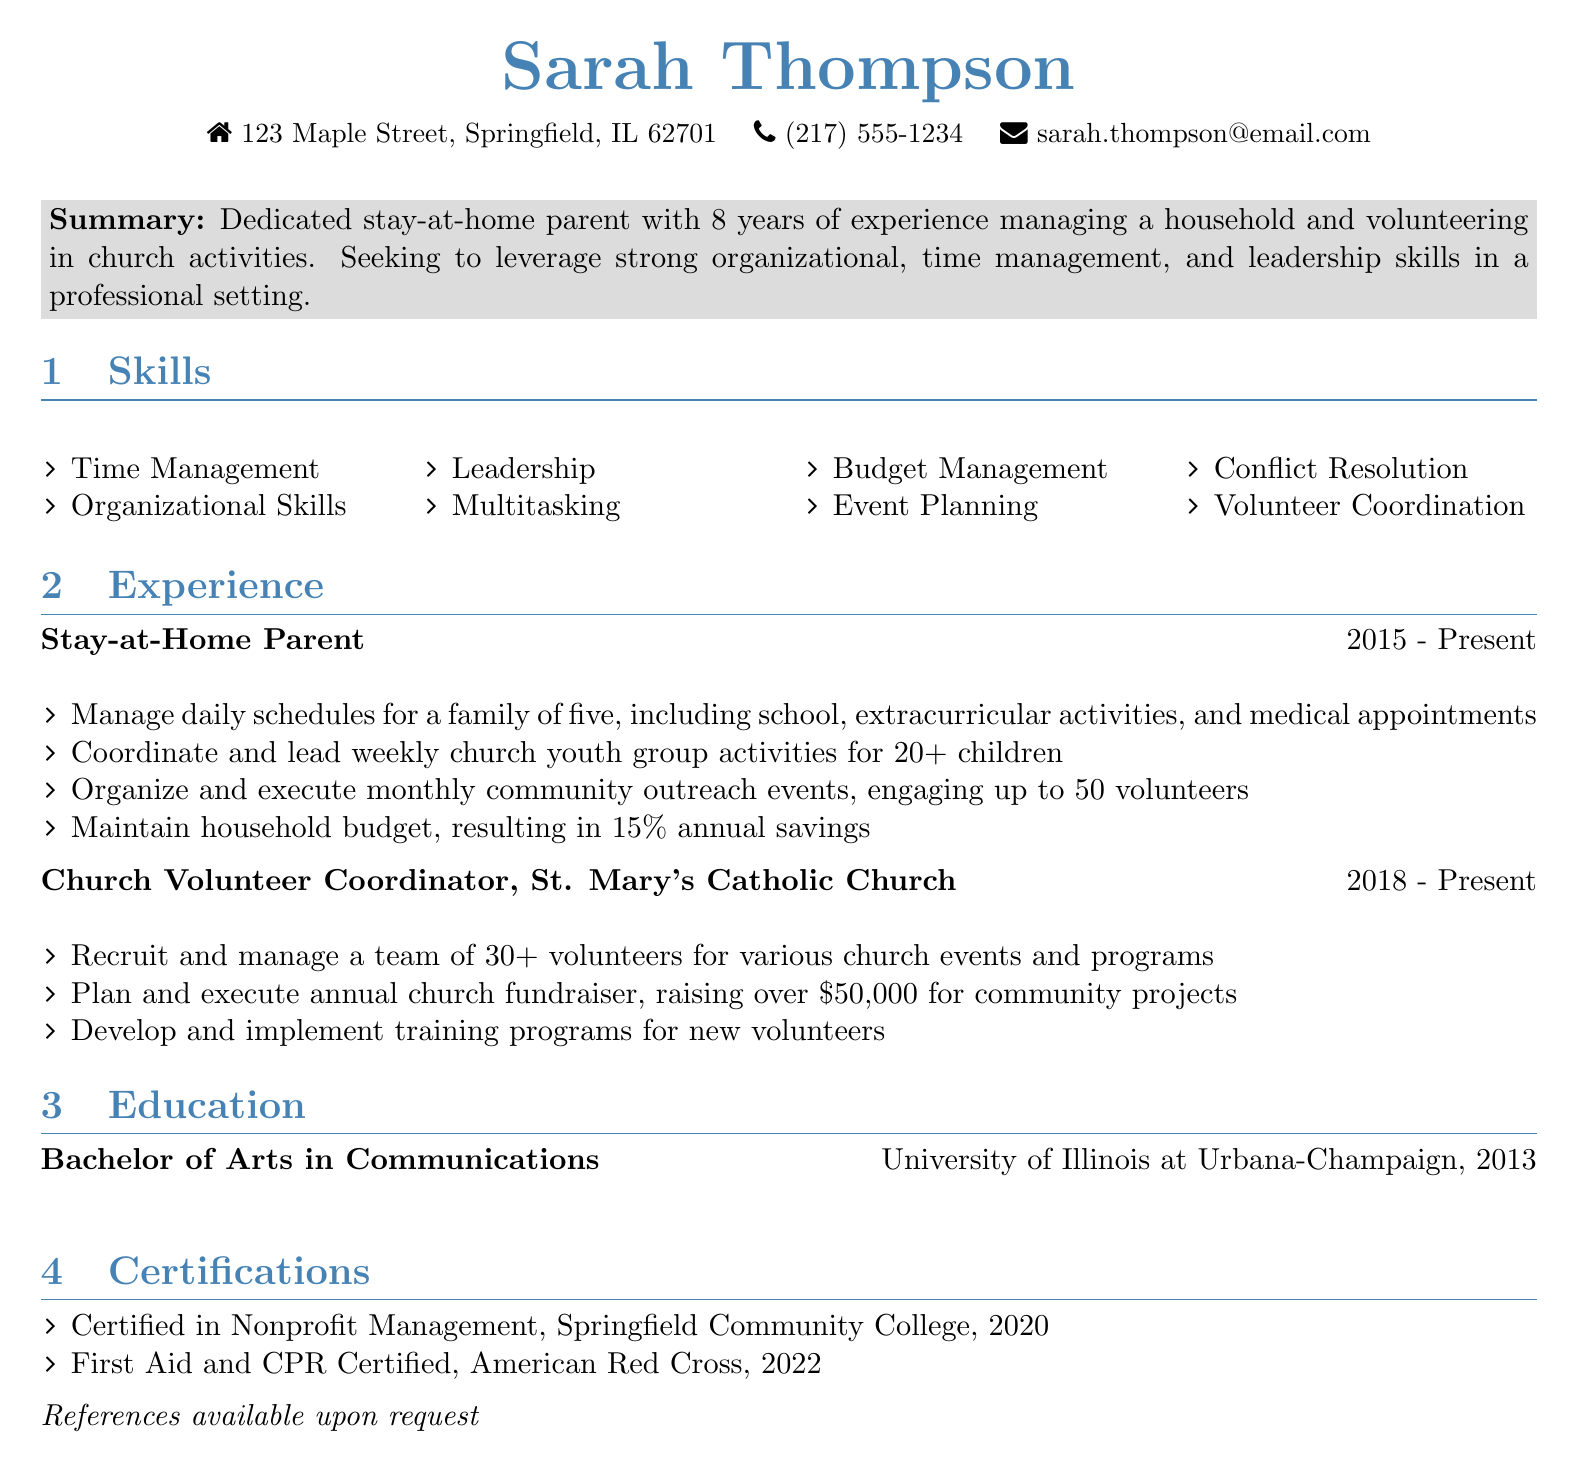what is the name of the individual? The name is presented prominently at the top of the document.
Answer: Sarah Thompson what is the address listed in the document? The address details are provided in the personal information section.
Answer: 123 Maple Street, Springfield, IL 62701 how many years of experience does Sarah have as a stay-at-home parent? The summary section specifies the duration of experience in years.
Answer: 8 years what is one of the skills mentioned? The skills section lists various competencies.
Answer: Time Management how many volunteers does Sarah manage for church events? This information is detailed in her experience as a Church Volunteer Coordinator.
Answer: 30+ what was the total amount raised from the annual church fundraiser? This number is mentioned under her responsibilities related to fundraising.
Answer: $50,000 what degree did Sarah earn? The education section states her academic qualification.
Answer: Bachelor of Arts in Communications which certification does Sarah hold related to health and safety? This information is specified in the certifications section.
Answer: First Aid and CPR Certified how many children are involved in the weekly church youth group activities? The experience description indicates the number of children participating.
Answer: 20+ what is the result of Sarah's household budget management? The responsibilities detail the outcome of her budgeting efforts.
Answer: 15% annual savings 